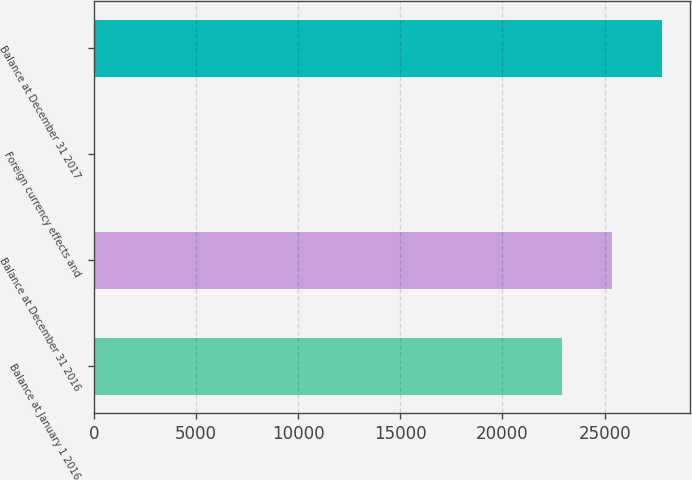Convert chart to OTSL. <chart><loc_0><loc_0><loc_500><loc_500><bar_chart><fcel>Balance at January 1 2016<fcel>Balance at December 31 2016<fcel>Foreign currency effects and<fcel>Balance at December 31 2017<nl><fcel>22925<fcel>25367.4<fcel>60<fcel>27809.8<nl></chart> 